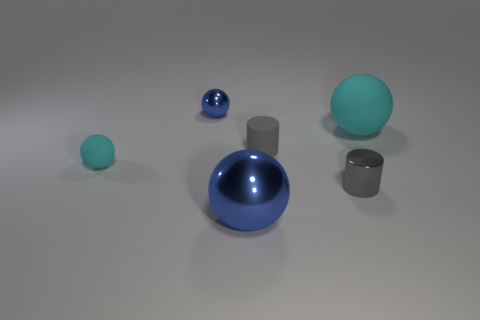Are there fewer tiny spheres that are behind the small rubber ball than spheres left of the metal cylinder?
Make the answer very short. Yes. What number of objects are big brown metallic blocks or blue metallic things in front of the large cyan matte ball?
Ensure brevity in your answer.  1. There is a cyan ball that is the same size as the gray metallic cylinder; what material is it?
Offer a terse response. Rubber. Is the large blue object made of the same material as the tiny blue ball?
Your answer should be very brief. Yes. What color is the thing that is both to the right of the tiny gray matte cylinder and in front of the large cyan object?
Keep it short and to the point. Gray. Is the color of the big sphere that is in front of the gray metallic thing the same as the big matte object?
Make the answer very short. No. What is the shape of the cyan thing that is the same size as the gray shiny thing?
Give a very brief answer. Sphere. What number of other objects are there of the same color as the small matte sphere?
Ensure brevity in your answer.  1. How many other objects are there of the same material as the small blue object?
Your answer should be compact. 2. Do the rubber cylinder and the cyan rubber thing on the left side of the large shiny sphere have the same size?
Offer a terse response. Yes. 